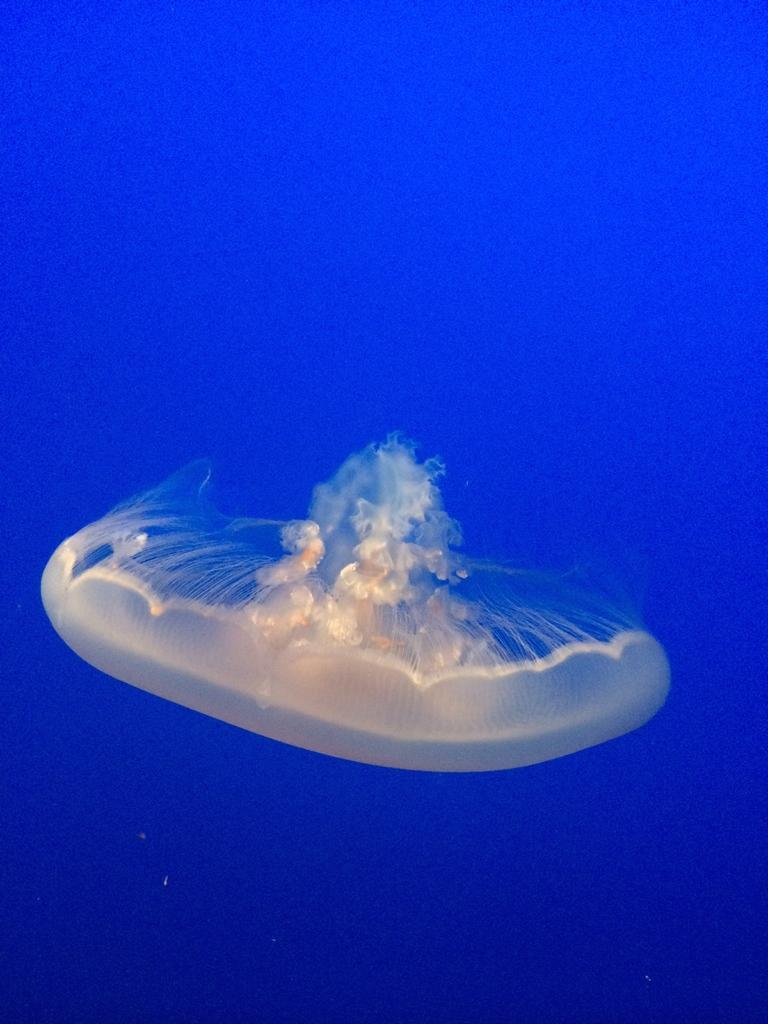What type of animal is in the image? There is a jellyfish in the image. Where is the jellyfish located? The jellyfish is in the water. What is the jellyfish's behavior when it comes to division in the image? There is no indication of the jellyfish's behavior regarding division in the image, as jellyfish do not perform mathematical operations. 